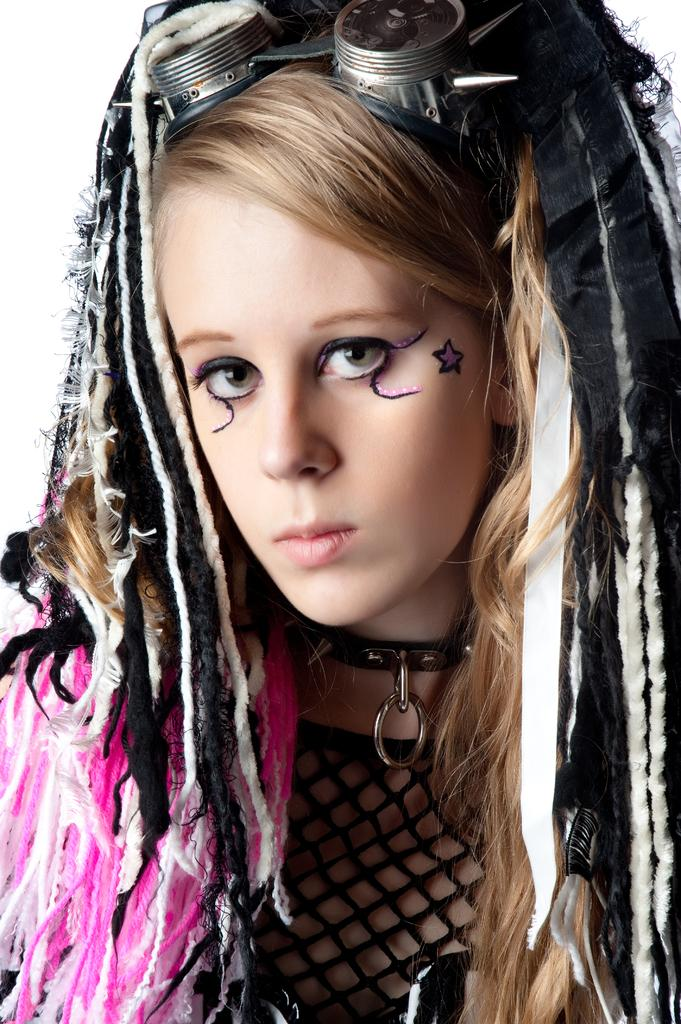Who is the main subject in the image? There is a girl in the image. Can you describe the girl's appearance? The girl has a different hairstyle. What type of magic is the girl performing in the garden? There is no mention of magic or a garden in the image; it only features a girl with a different hairstyle. 